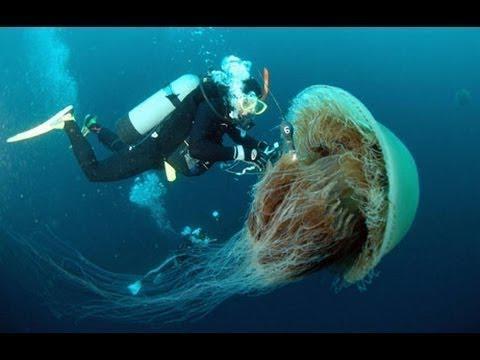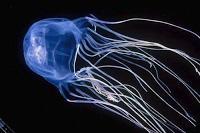The first image is the image on the left, the second image is the image on the right. For the images displayed, is the sentence "the right image has a lone jellyfish swimming to the left" factually correct? Answer yes or no. Yes. The first image is the image on the left, the second image is the image on the right. Given the left and right images, does the statement "There are a total of 2 jelly fish." hold true? Answer yes or no. Yes. 